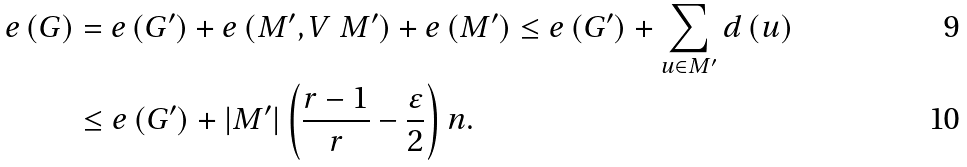Convert formula to latex. <formula><loc_0><loc_0><loc_500><loc_500>e \left ( G \right ) & = e \left ( G ^ { \prime } \right ) + e \left ( M ^ { \prime } , V \ M ^ { \prime } \right ) + e \left ( M ^ { \prime } \right ) \leq e \left ( G ^ { \prime } \right ) + \sum _ { u \in M ^ { \prime } } d \left ( u \right ) \\ & \leq e \left ( G ^ { \prime } \right ) + \left | M ^ { \prime } \right | \left ( \frac { r - 1 } { r } - \frac { \varepsilon } { 2 } \right ) n .</formula> 